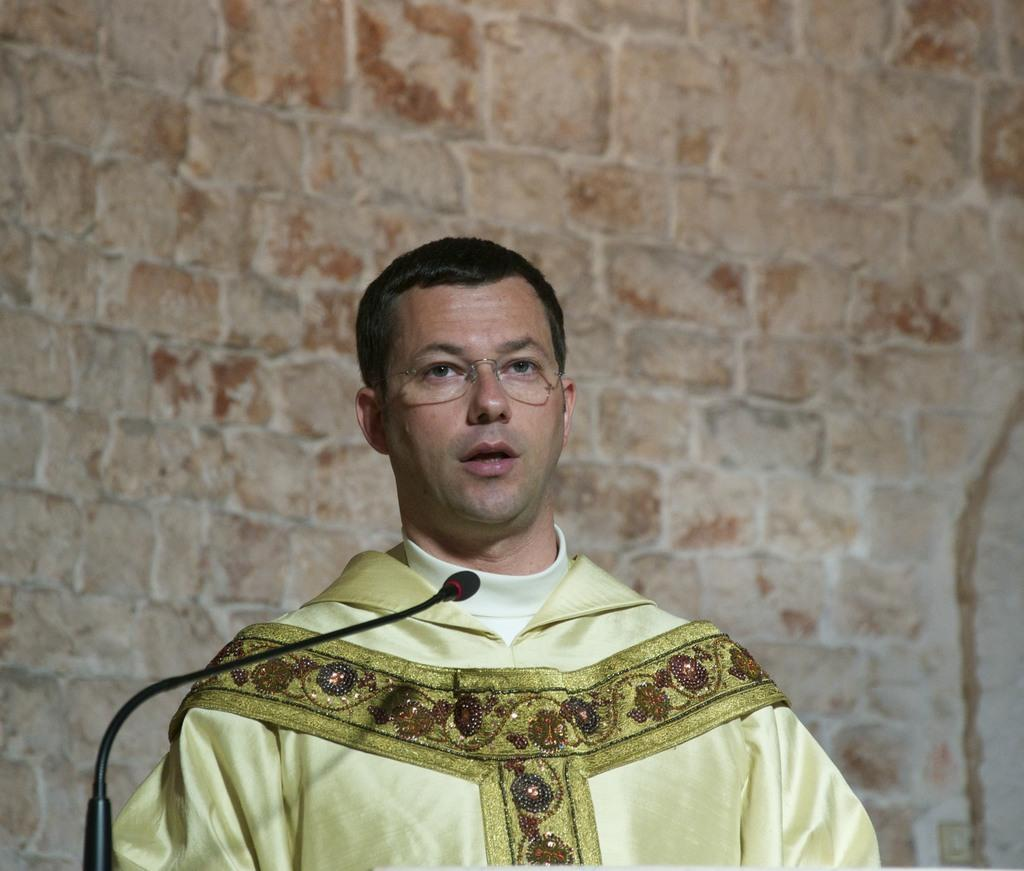What is the main subject of the image? There is a person standing in the image. What is the person doing in the image? The person is talking. What object is present that might be related to the person's activity? There is a microphone in the image. Can you describe any accessories the person is wearing? The person is wearing spectacles. What can be seen behind the person in the image? There is a wall behind the person. What type of corn is being used as a prop in the image? There is no corn present in the image. How many pieces of lumber are visible in the image? There is no lumber present in the image. 